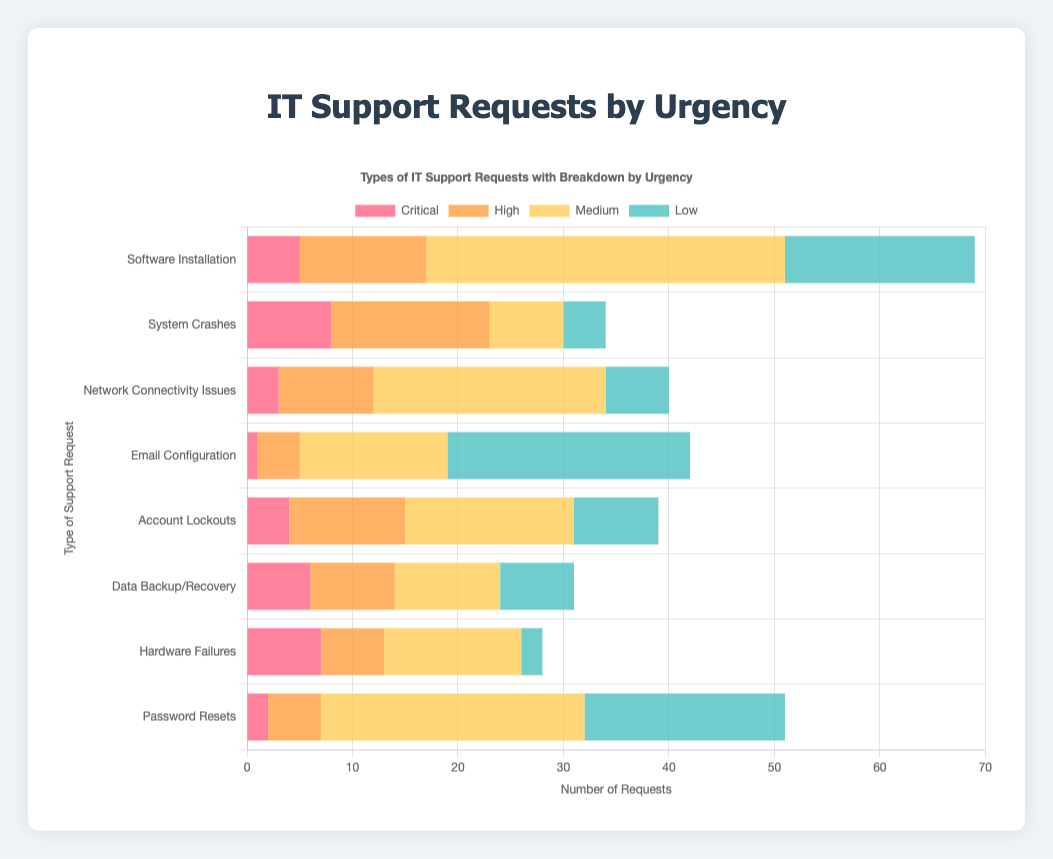Which type of IT support request has the highest number of critical cases? The chart shows bars for each request type stacked by urgency levels. The tallest red bar represents critical cases for "System Crashes" with a count of 8.
Answer: System Crashes What is the total number of high urgency requests for 'Software Installation' and 'Network Connectivity Issues' combined? The chart shows the 'High' urgency (orange bars) values for 'Software Installation' (12) and 'Network Connectivity Issues' (9). Adding these together gives 12 + 9 = 21.
Answer: 21 Which request type has more low urgency requests: 'Email Configuration' or 'Password Resets'? The chart shows in the 'Low' urgency (green bars) category: 'Email Configuration' has 23 and 'Password Resets' has 19. As 23 > 19, 'Email Configuration' has more low urgency requests.
Answer: Email Configuration What is the difference in the number of medium urgency requests between 'Software Installation' and 'Hardware Failures'? The chart shows the 'Medium' urgency (yellow bars) values: 'Software Installation' has 34 and 'Hardware Failures' has 13. The difference is 34 - 13 = 21.
Answer: 21 How many total requests of any urgency does 'Data Backup/Recovery' have? For 'Data Backup/Recovery', sum all urgency counts: 6 (Critical) + 8 (High) + 10 (Medium) + 7 (Low). Thus, the total is 6 + 8 + 10 + 7 = 31.
Answer: 31 What is the type of IT support request with the smallest number of medium urgency cases? The chart's 'Medium' urgency (yellow bars) values show: 'System Crashes' has the smallest value with 7 medium urgency cases compared to other types.
Answer: System Crashes Which urgency level has the highest request count for 'Account Lockouts'? The four urgency levels for 'Account Lockouts' show: 4 (Critical), 11 (High), 16 (Medium), 8 (Low). 'Medium' with 16 is the highest.
Answer: Medium Of all types, which has the fewest high urgency requests? The chart's 'High' urgency (orange bars) counts show: 'Email Configuration' has the smallest value with 4 high urgency cases.
Answer: Email Configuration 